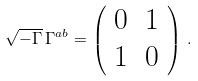<formula> <loc_0><loc_0><loc_500><loc_500>\sqrt { - \Gamma } \, \Gamma ^ { a b } = \left ( \begin{array} { l l } 0 & 1 \\ 1 & 0 \end{array} \right ) \, .</formula> 